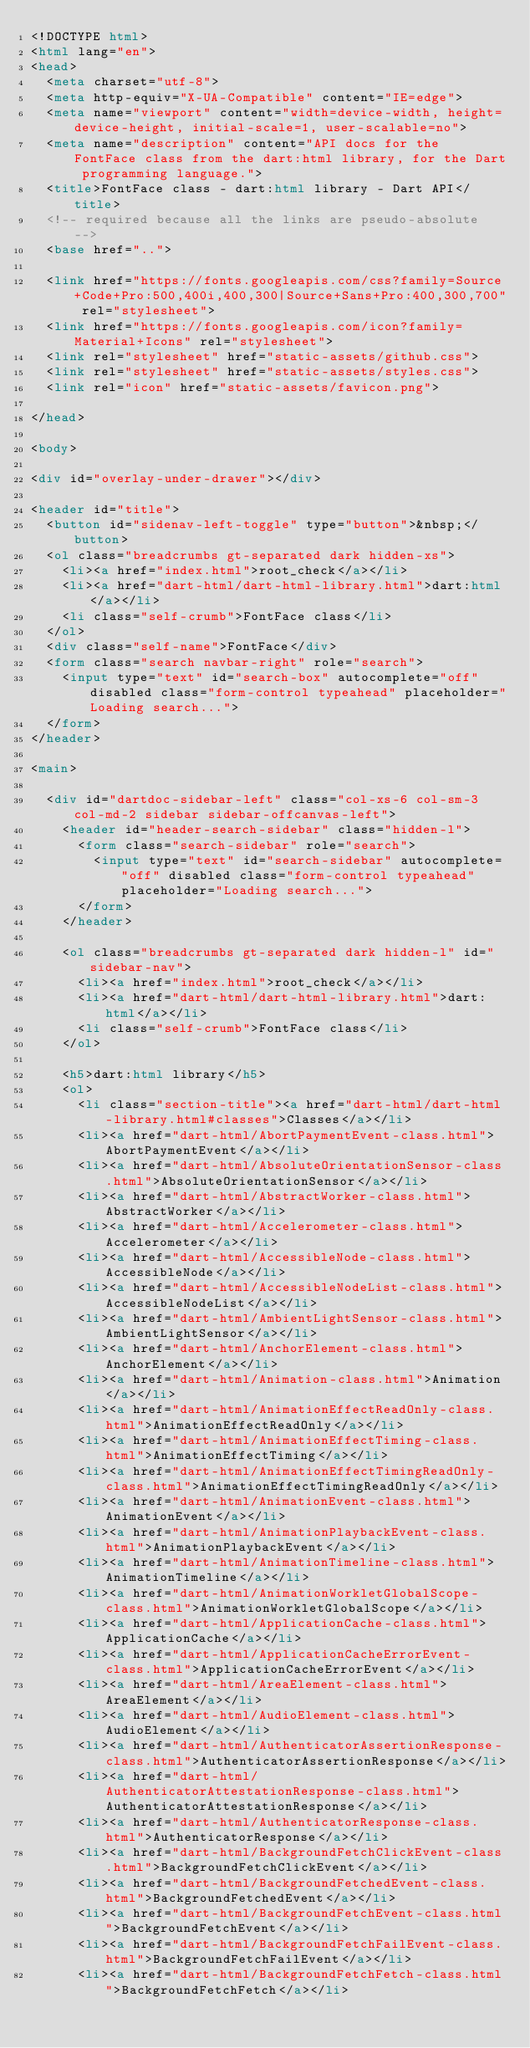Convert code to text. <code><loc_0><loc_0><loc_500><loc_500><_HTML_><!DOCTYPE html>
<html lang="en">
<head>
  <meta charset="utf-8">
  <meta http-equiv="X-UA-Compatible" content="IE=edge">
  <meta name="viewport" content="width=device-width, height=device-height, initial-scale=1, user-scalable=no">
  <meta name="description" content="API docs for the FontFace class from the dart:html library, for the Dart programming language.">
  <title>FontFace class - dart:html library - Dart API</title>
  <!-- required because all the links are pseudo-absolute -->
  <base href="..">

  <link href="https://fonts.googleapis.com/css?family=Source+Code+Pro:500,400i,400,300|Source+Sans+Pro:400,300,700" rel="stylesheet">
  <link href="https://fonts.googleapis.com/icon?family=Material+Icons" rel="stylesheet">
  <link rel="stylesheet" href="static-assets/github.css">
  <link rel="stylesheet" href="static-assets/styles.css">
  <link rel="icon" href="static-assets/favicon.png">
  
</head>

<body>

<div id="overlay-under-drawer"></div>

<header id="title">
  <button id="sidenav-left-toggle" type="button">&nbsp;</button>
  <ol class="breadcrumbs gt-separated dark hidden-xs">
    <li><a href="index.html">root_check</a></li>
    <li><a href="dart-html/dart-html-library.html">dart:html</a></li>
    <li class="self-crumb">FontFace class</li>
  </ol>
  <div class="self-name">FontFace</div>
  <form class="search navbar-right" role="search">
    <input type="text" id="search-box" autocomplete="off" disabled class="form-control typeahead" placeholder="Loading search...">
  </form>
</header>

<main>

  <div id="dartdoc-sidebar-left" class="col-xs-6 col-sm-3 col-md-2 sidebar sidebar-offcanvas-left">
    <header id="header-search-sidebar" class="hidden-l">
      <form class="search-sidebar" role="search">
        <input type="text" id="search-sidebar" autocomplete="off" disabled class="form-control typeahead" placeholder="Loading search...">
      </form>
    </header>
    
    <ol class="breadcrumbs gt-separated dark hidden-l" id="sidebar-nav">
      <li><a href="index.html">root_check</a></li>
      <li><a href="dart-html/dart-html-library.html">dart:html</a></li>
      <li class="self-crumb">FontFace class</li>
    </ol>
    
    <h5>dart:html library</h5>
    <ol>
      <li class="section-title"><a href="dart-html/dart-html-library.html#classes">Classes</a></li>
      <li><a href="dart-html/AbortPaymentEvent-class.html">AbortPaymentEvent</a></li>
      <li><a href="dart-html/AbsoluteOrientationSensor-class.html">AbsoluteOrientationSensor</a></li>
      <li><a href="dart-html/AbstractWorker-class.html">AbstractWorker</a></li>
      <li><a href="dart-html/Accelerometer-class.html">Accelerometer</a></li>
      <li><a href="dart-html/AccessibleNode-class.html">AccessibleNode</a></li>
      <li><a href="dart-html/AccessibleNodeList-class.html">AccessibleNodeList</a></li>
      <li><a href="dart-html/AmbientLightSensor-class.html">AmbientLightSensor</a></li>
      <li><a href="dart-html/AnchorElement-class.html">AnchorElement</a></li>
      <li><a href="dart-html/Animation-class.html">Animation</a></li>
      <li><a href="dart-html/AnimationEffectReadOnly-class.html">AnimationEffectReadOnly</a></li>
      <li><a href="dart-html/AnimationEffectTiming-class.html">AnimationEffectTiming</a></li>
      <li><a href="dart-html/AnimationEffectTimingReadOnly-class.html">AnimationEffectTimingReadOnly</a></li>
      <li><a href="dart-html/AnimationEvent-class.html">AnimationEvent</a></li>
      <li><a href="dart-html/AnimationPlaybackEvent-class.html">AnimationPlaybackEvent</a></li>
      <li><a href="dart-html/AnimationTimeline-class.html">AnimationTimeline</a></li>
      <li><a href="dart-html/AnimationWorkletGlobalScope-class.html">AnimationWorkletGlobalScope</a></li>
      <li><a href="dart-html/ApplicationCache-class.html">ApplicationCache</a></li>
      <li><a href="dart-html/ApplicationCacheErrorEvent-class.html">ApplicationCacheErrorEvent</a></li>
      <li><a href="dart-html/AreaElement-class.html">AreaElement</a></li>
      <li><a href="dart-html/AudioElement-class.html">AudioElement</a></li>
      <li><a href="dart-html/AuthenticatorAssertionResponse-class.html">AuthenticatorAssertionResponse</a></li>
      <li><a href="dart-html/AuthenticatorAttestationResponse-class.html">AuthenticatorAttestationResponse</a></li>
      <li><a href="dart-html/AuthenticatorResponse-class.html">AuthenticatorResponse</a></li>
      <li><a href="dart-html/BackgroundFetchClickEvent-class.html">BackgroundFetchClickEvent</a></li>
      <li><a href="dart-html/BackgroundFetchedEvent-class.html">BackgroundFetchedEvent</a></li>
      <li><a href="dart-html/BackgroundFetchEvent-class.html">BackgroundFetchEvent</a></li>
      <li><a href="dart-html/BackgroundFetchFailEvent-class.html">BackgroundFetchFailEvent</a></li>
      <li><a href="dart-html/BackgroundFetchFetch-class.html">BackgroundFetchFetch</a></li></code> 